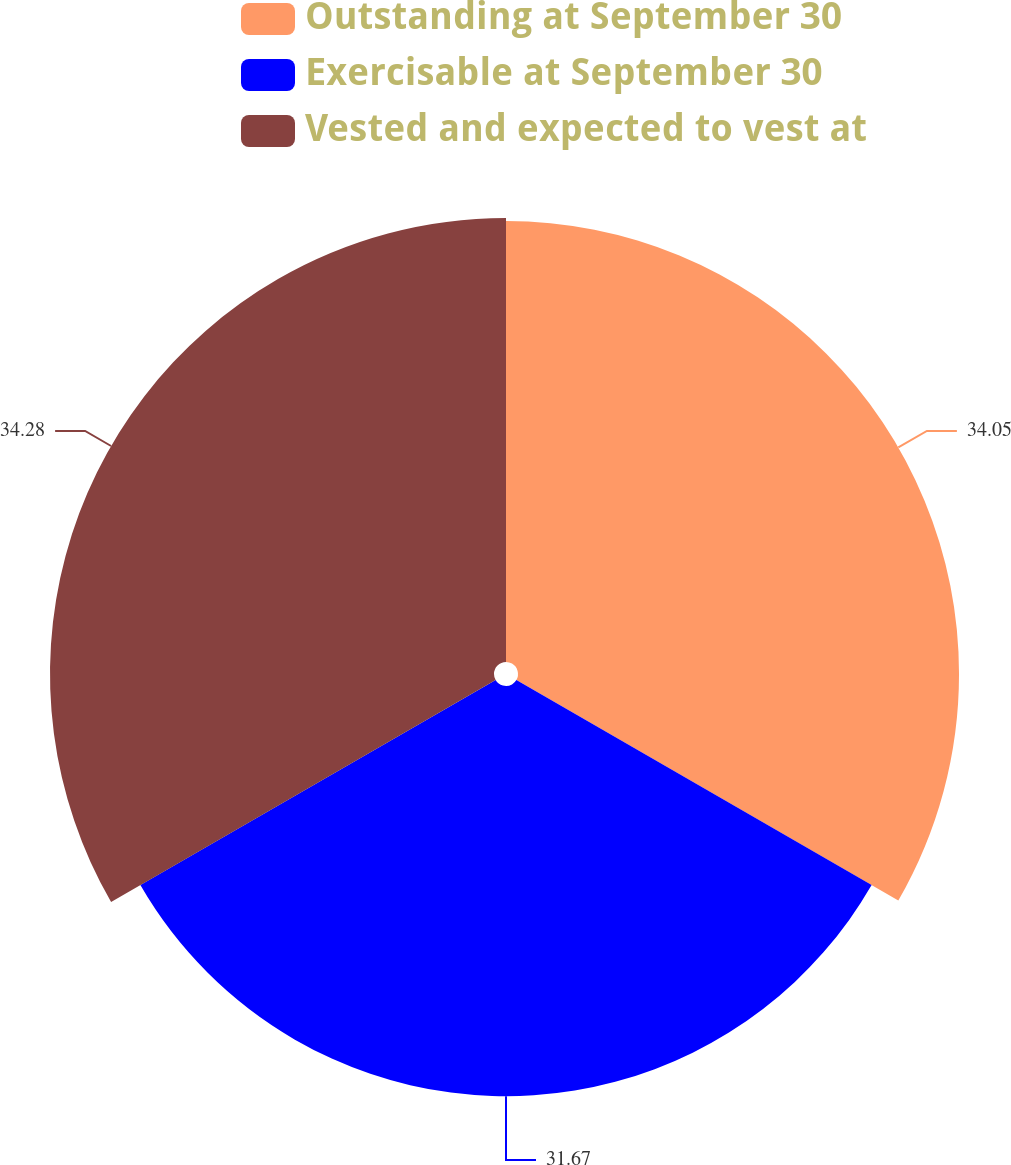Convert chart to OTSL. <chart><loc_0><loc_0><loc_500><loc_500><pie_chart><fcel>Outstanding at September 30<fcel>Exercisable at September 30<fcel>Vested and expected to vest at<nl><fcel>34.05%<fcel>31.67%<fcel>34.28%<nl></chart> 